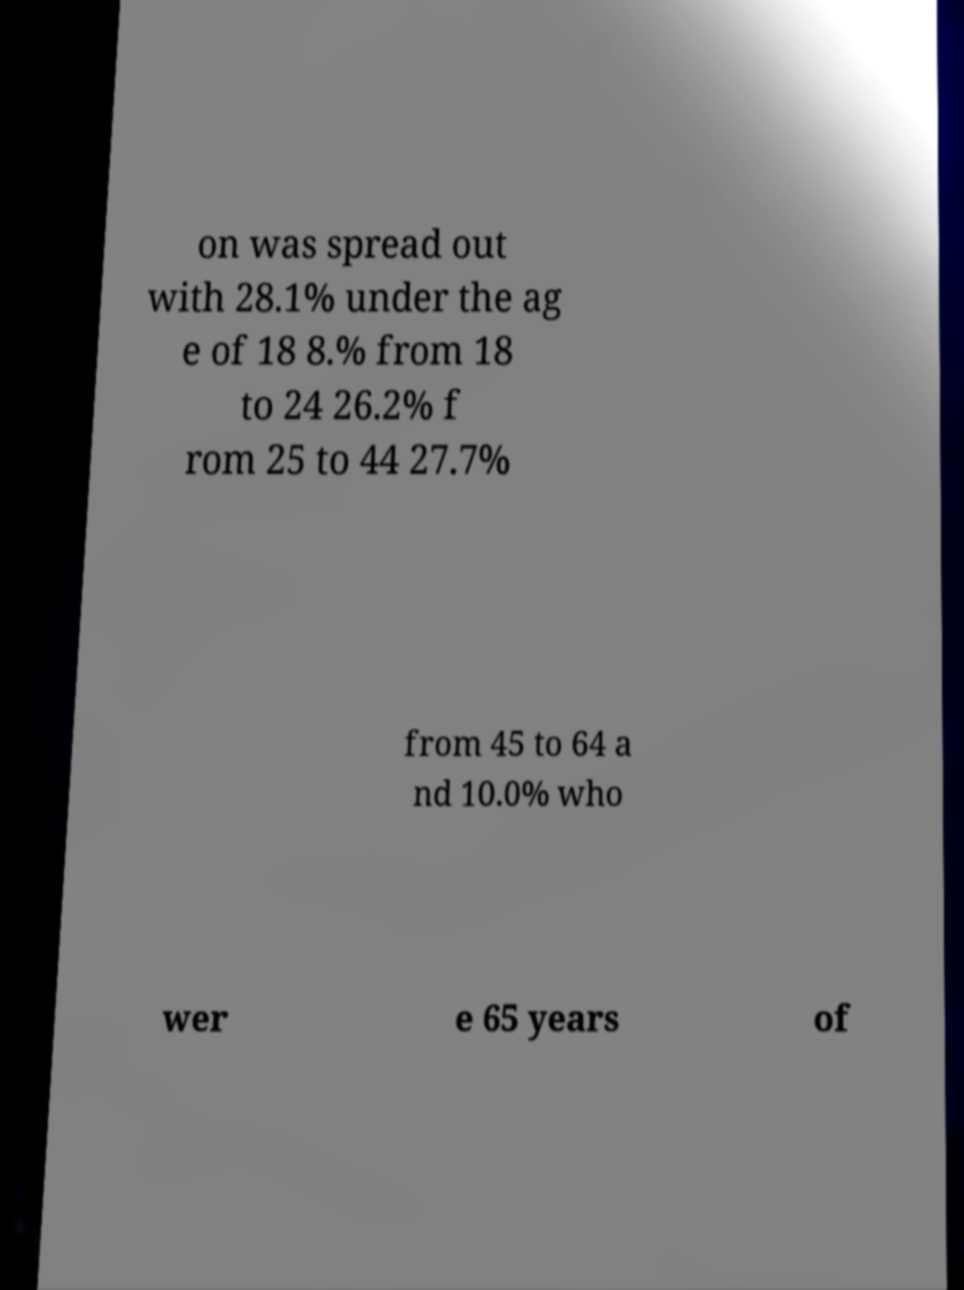Can you read and provide the text displayed in the image?This photo seems to have some interesting text. Can you extract and type it out for me? on was spread out with 28.1% under the ag e of 18 8.% from 18 to 24 26.2% f rom 25 to 44 27.7% from 45 to 64 a nd 10.0% who wer e 65 years of 